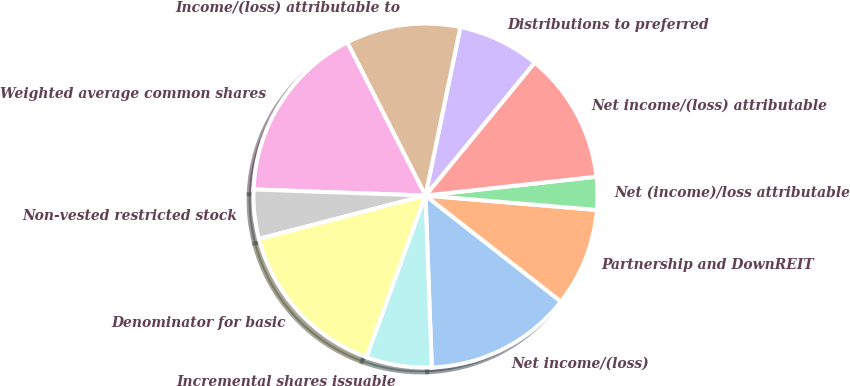Convert chart. <chart><loc_0><loc_0><loc_500><loc_500><pie_chart><fcel>Net income/(loss)<fcel>Partnership and DownREIT<fcel>Net (income)/loss attributable<fcel>Net income/(loss) attributable<fcel>Distributions to preferred<fcel>Income/(loss) attributable to<fcel>Weighted average common shares<fcel>Non-vested restricted stock<fcel>Denominator for basic<fcel>Incremental shares issuable<nl><fcel>13.85%<fcel>9.23%<fcel>3.08%<fcel>12.31%<fcel>7.69%<fcel>10.77%<fcel>16.92%<fcel>4.62%<fcel>15.38%<fcel>6.15%<nl></chart> 